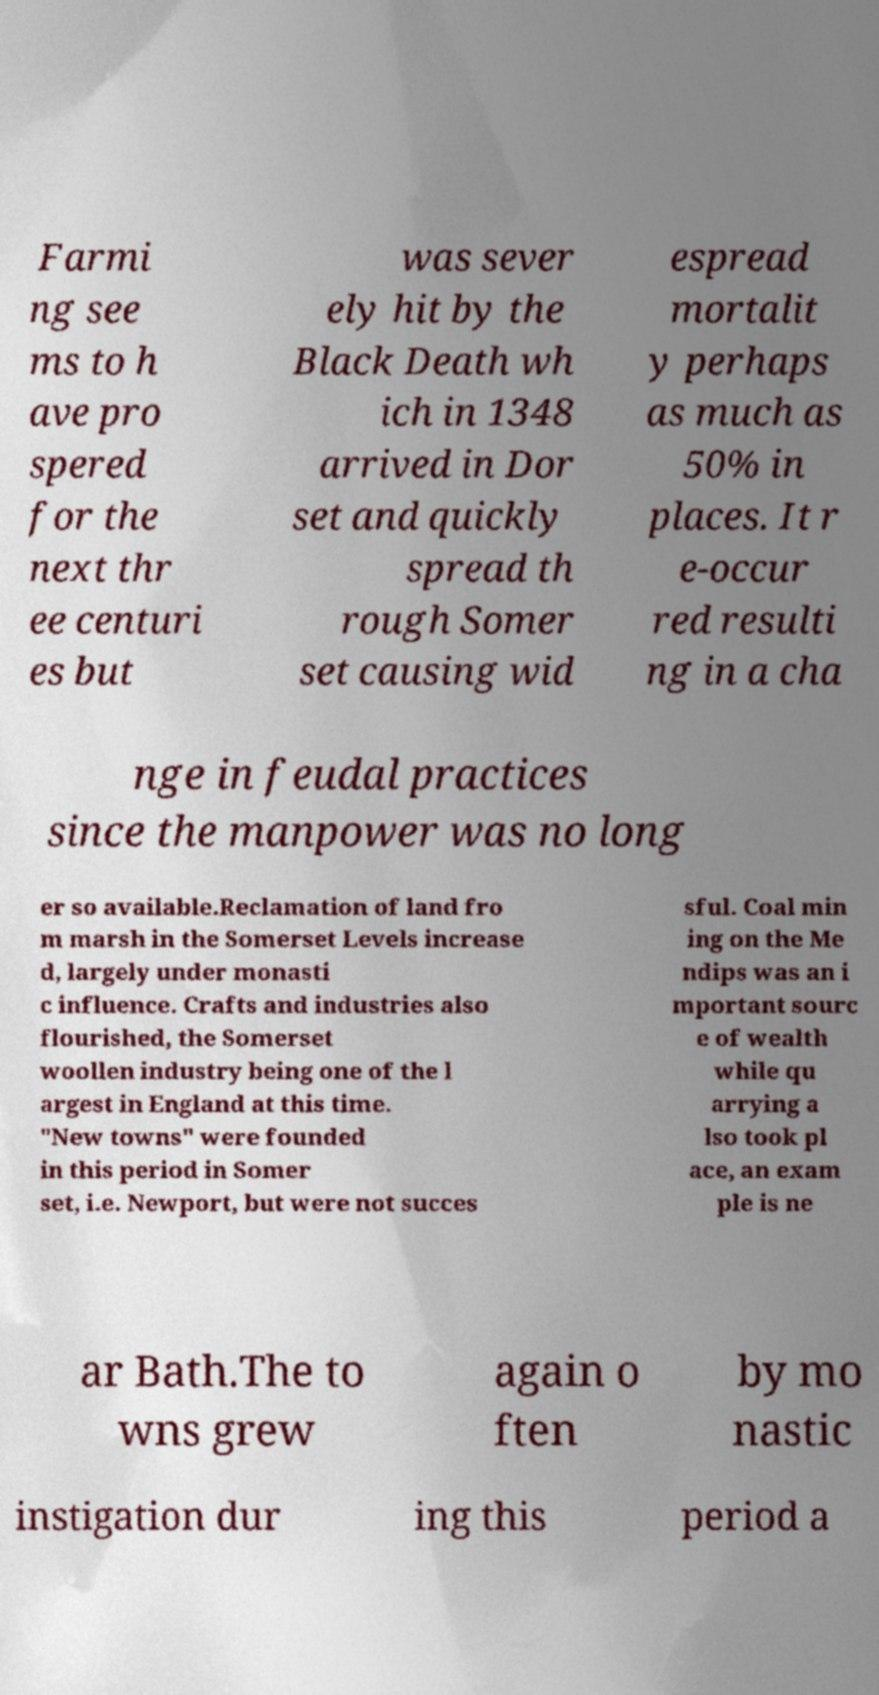Can you accurately transcribe the text from the provided image for me? Farmi ng see ms to h ave pro spered for the next thr ee centuri es but was sever ely hit by the Black Death wh ich in 1348 arrived in Dor set and quickly spread th rough Somer set causing wid espread mortalit y perhaps as much as 50% in places. It r e-occur red resulti ng in a cha nge in feudal practices since the manpower was no long er so available.Reclamation of land fro m marsh in the Somerset Levels increase d, largely under monasti c influence. Crafts and industries also flourished, the Somerset woollen industry being one of the l argest in England at this time. "New towns" were founded in this period in Somer set, i.e. Newport, but were not succes sful. Coal min ing on the Me ndips was an i mportant sourc e of wealth while qu arrying a lso took pl ace, an exam ple is ne ar Bath.The to wns grew again o ften by mo nastic instigation dur ing this period a 